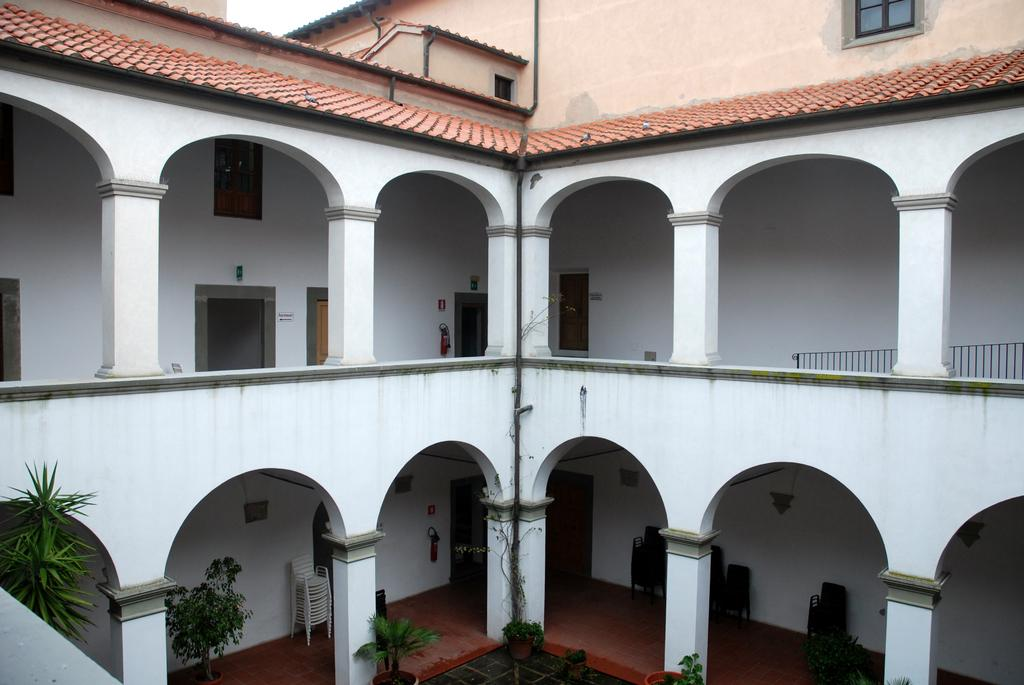What type of structure is present in the image? There is a building in the image. What features can be seen on the building? The building has doors, windows, pillars, and walls. What type of vegetation is visible in the image? There are plants and trees in the image. What type of furniture is present in the image? There are chairs in the image. Can you tell me how many times the yoke bursts in the image? There is no yoke present in the image, and therefore no bursting can be observed. 